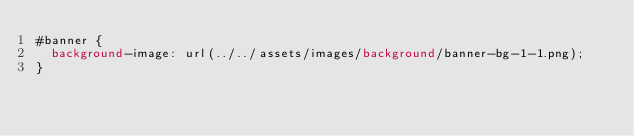Convert code to text. <code><loc_0><loc_0><loc_500><loc_500><_CSS_>#banner {
  background-image: url(../../assets/images/background/banner-bg-1-1.png);
}
</code> 